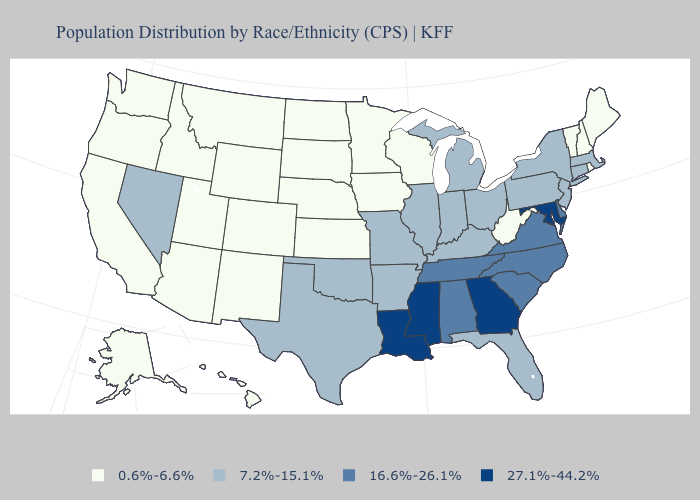Among the states that border Connecticut , does Rhode Island have the highest value?
Be succinct. No. Name the states that have a value in the range 0.6%-6.6%?
Write a very short answer. Alaska, Arizona, California, Colorado, Hawaii, Idaho, Iowa, Kansas, Maine, Minnesota, Montana, Nebraska, New Hampshire, New Mexico, North Dakota, Oregon, Rhode Island, South Dakota, Utah, Vermont, Washington, West Virginia, Wisconsin, Wyoming. Does the first symbol in the legend represent the smallest category?
Concise answer only. Yes. What is the value of New Mexico?
Be succinct. 0.6%-6.6%. Does the map have missing data?
Short answer required. No. Name the states that have a value in the range 16.6%-26.1%?
Keep it brief. Alabama, Delaware, North Carolina, South Carolina, Tennessee, Virginia. Does New Hampshire have the highest value in the Northeast?
Write a very short answer. No. Name the states that have a value in the range 27.1%-44.2%?
Concise answer only. Georgia, Louisiana, Maryland, Mississippi. Does Kansas have the same value as Nevada?
Answer briefly. No. Name the states that have a value in the range 0.6%-6.6%?
Quick response, please. Alaska, Arizona, California, Colorado, Hawaii, Idaho, Iowa, Kansas, Maine, Minnesota, Montana, Nebraska, New Hampshire, New Mexico, North Dakota, Oregon, Rhode Island, South Dakota, Utah, Vermont, Washington, West Virginia, Wisconsin, Wyoming. Does the map have missing data?
Write a very short answer. No. Does North Dakota have a higher value than Alaska?
Give a very brief answer. No. Name the states that have a value in the range 27.1%-44.2%?
Quick response, please. Georgia, Louisiana, Maryland, Mississippi. Name the states that have a value in the range 7.2%-15.1%?
Write a very short answer. Arkansas, Connecticut, Florida, Illinois, Indiana, Kentucky, Massachusetts, Michigan, Missouri, Nevada, New Jersey, New York, Ohio, Oklahoma, Pennsylvania, Texas. 